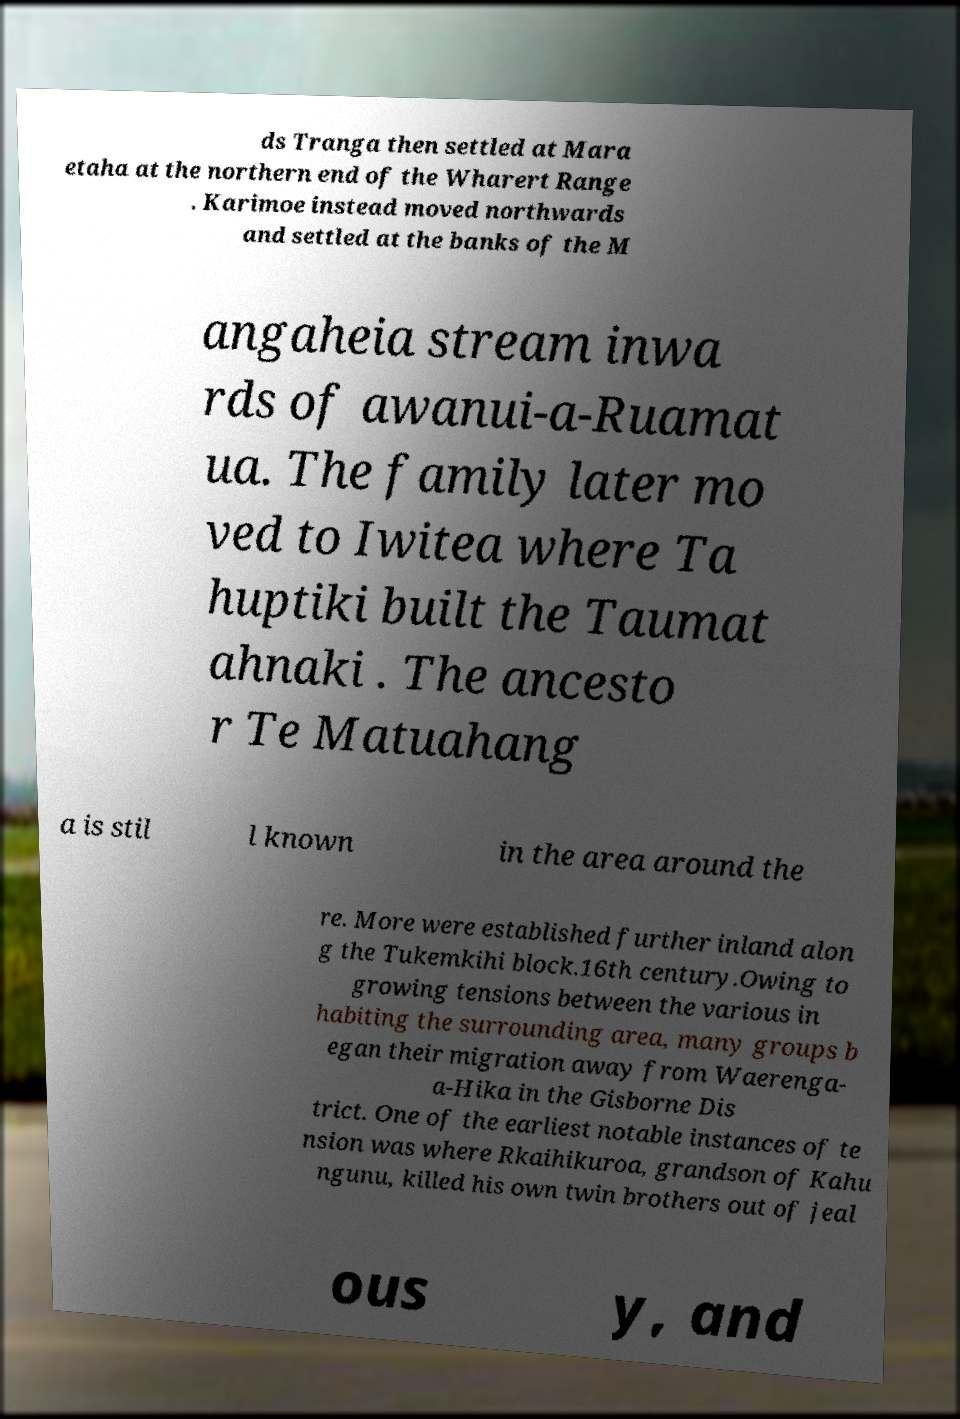Please identify and transcribe the text found in this image. ds Tranga then settled at Mara etaha at the northern end of the Wharert Range . Karimoe instead moved northwards and settled at the banks of the M angaheia stream inwa rds of awanui-a-Ruamat ua. The family later mo ved to Iwitea where Ta huptiki built the Taumat ahnaki . The ancesto r Te Matuahang a is stil l known in the area around the re. More were established further inland alon g the Tukemkihi block.16th century.Owing to growing tensions between the various in habiting the surrounding area, many groups b egan their migration away from Waerenga- a-Hika in the Gisborne Dis trict. One of the earliest notable instances of te nsion was where Rkaihikuroa, grandson of Kahu ngunu, killed his own twin brothers out of jeal ous y, and 